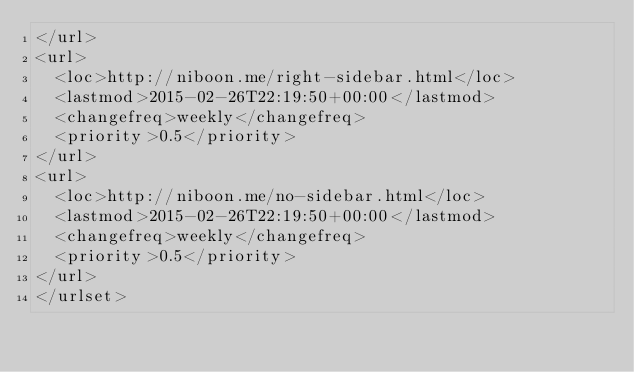Convert code to text. <code><loc_0><loc_0><loc_500><loc_500><_XML_></url>
<url>
  <loc>http://niboon.me/right-sidebar.html</loc>
  <lastmod>2015-02-26T22:19:50+00:00</lastmod>
  <changefreq>weekly</changefreq>
  <priority>0.5</priority>
</url>
<url>
  <loc>http://niboon.me/no-sidebar.html</loc>
  <lastmod>2015-02-26T22:19:50+00:00</lastmod>
  <changefreq>weekly</changefreq>
  <priority>0.5</priority>
</url>
</urlset></code> 